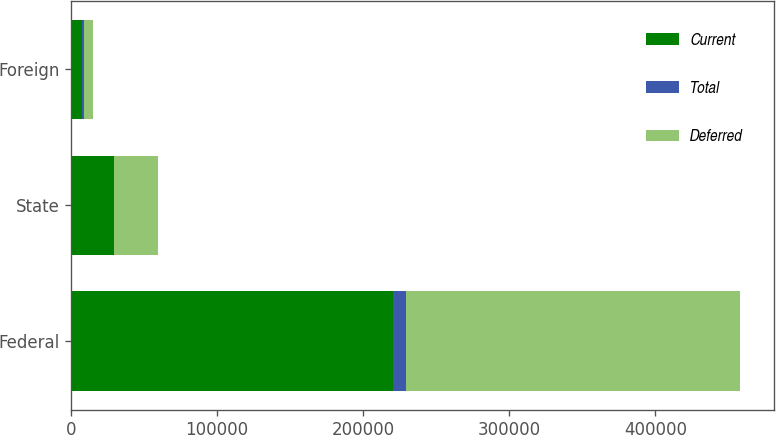Convert chart to OTSL. <chart><loc_0><loc_0><loc_500><loc_500><stacked_bar_chart><ecel><fcel>Federal<fcel>State<fcel>Foreign<nl><fcel>Current<fcel>220588<fcel>29073<fcel>7487<nl><fcel>Total<fcel>8547<fcel>527<fcel>1390<nl><fcel>Deferred<fcel>229135<fcel>29600<fcel>6097<nl></chart> 